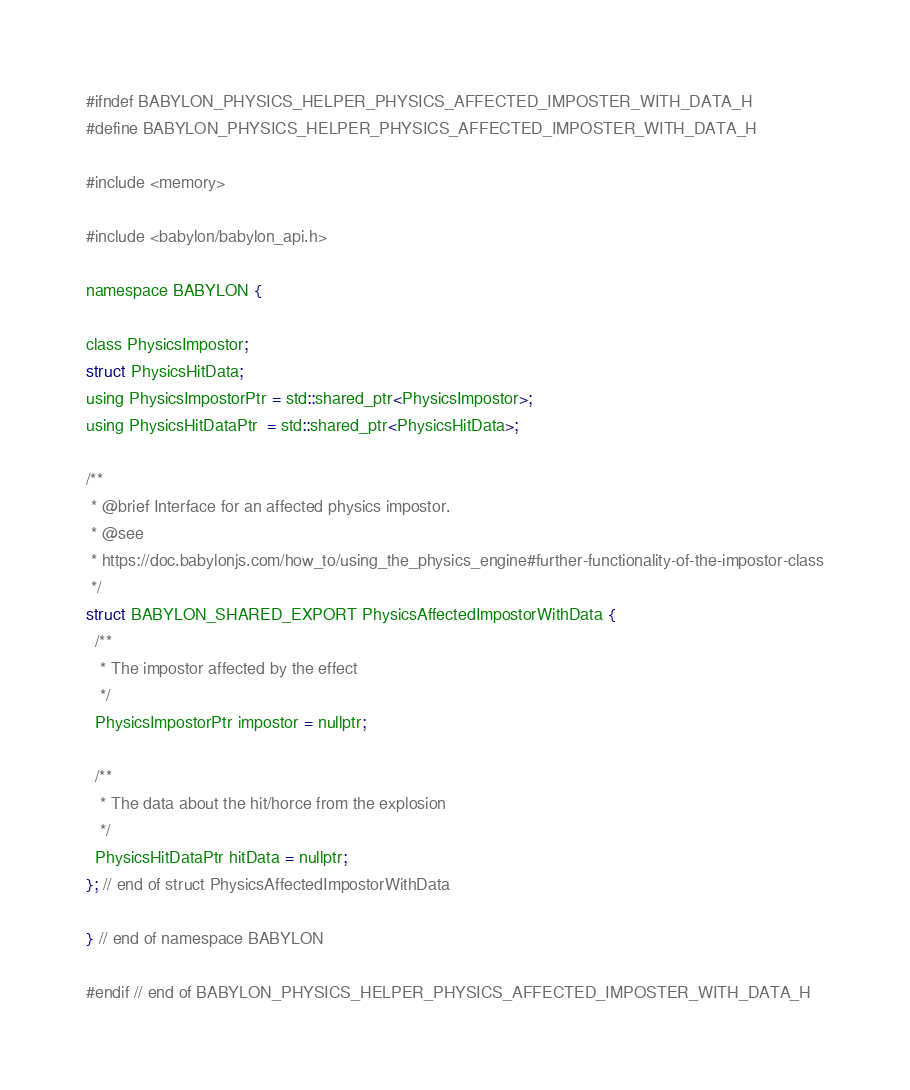<code> <loc_0><loc_0><loc_500><loc_500><_C_>#ifndef BABYLON_PHYSICS_HELPER_PHYSICS_AFFECTED_IMPOSTER_WITH_DATA_H
#define BABYLON_PHYSICS_HELPER_PHYSICS_AFFECTED_IMPOSTER_WITH_DATA_H

#include <memory>

#include <babylon/babylon_api.h>

namespace BABYLON {

class PhysicsImpostor;
struct PhysicsHitData;
using PhysicsImpostorPtr = std::shared_ptr<PhysicsImpostor>;
using PhysicsHitDataPtr  = std::shared_ptr<PhysicsHitData>;

/**
 * @brief Interface for an affected physics impostor.
 * @see
 * https://doc.babylonjs.com/how_to/using_the_physics_engine#further-functionality-of-the-impostor-class
 */
struct BABYLON_SHARED_EXPORT PhysicsAffectedImpostorWithData {
  /**
   * The impostor affected by the effect
   */
  PhysicsImpostorPtr impostor = nullptr;

  /**
   * The data about the hit/horce from the explosion
   */
  PhysicsHitDataPtr hitData = nullptr;
}; // end of struct PhysicsAffectedImpostorWithData

} // end of namespace BABYLON

#endif // end of BABYLON_PHYSICS_HELPER_PHYSICS_AFFECTED_IMPOSTER_WITH_DATA_H
</code> 